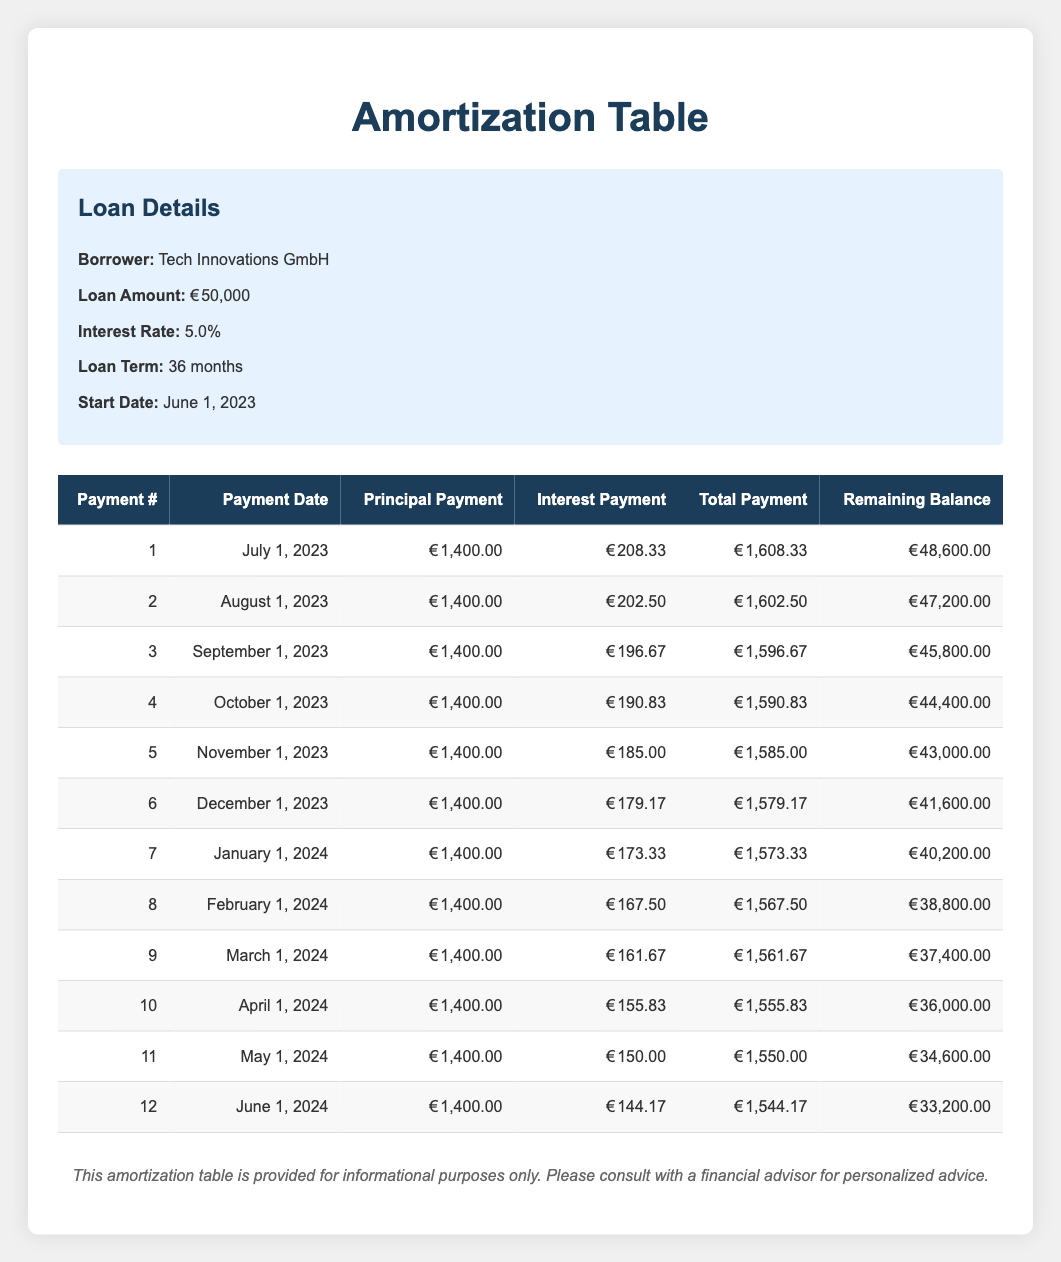What is the total payment for the first month? The first month is represented as payment number 1 in the table. The total payment for this month is given as 1,608.33.
Answer: 1,608.33 How much is the principal payment after 6 months? The principal payment is constant at 1,400.00 for each month. After 6 months, the total principal paid is 1,400.00 * 6 = 8,400.00.
Answer: 8,400.00 Is the interest payment decreasing with each payment? In the provided payment schedule, each month's interest payment is lower than the previous one, which indicates a decrease.
Answer: Yes What is the remaining balance after the 12th payment? The table shows that the remaining balance after the 12th payment is 33,200.00.
Answer: 33,200.00 What is the average total payment over the first 6 months? The total payments for the first 6 months are 1,608.33, 1,602.50, 1,596.67, 1,590.83, 1,585.00, and 1,579.17. Summing these gives 9,162.50. To get the average, divide this by 6: 9,162.50 / 6 = 1,527.08.
Answer: 1,527.08 What is the total interest paid in the first quarter (first 3 payments)? The interest payments for the first three payments are 208.33, 202.50, and 196.67. Adding these gives 208.33 + 202.50 + 196.67 = 607.50.
Answer: 607.50 How much total amount is paid by the end of the 6th month? The total payments for the first 6 months are 1,608.33 + 1,602.50 + 1,596.67 + 1,590.83 + 1,585.00 + 1,579.17, which totals to 9,162.50.
Answer: 9,162.50 What is the interest payment on the 8th payment? The interest payment for the 8th payment can be found in the table and is recorded as 167.50.
Answer: 167.50 How much principal is left to pay after 4 months? The total principal paid after 4 months is 1,400.00 * 4 = 5,600.00. The remaining balance after 4 months is shown as 44,400.00, so the remaining principal to pay is 50,000.00 - 5,600.00 = 44,400.00, confirming the balance in the table.
Answer: 44,400.00 